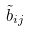Convert formula to latex. <formula><loc_0><loc_0><loc_500><loc_500>\tilde { b } _ { i j }</formula> 